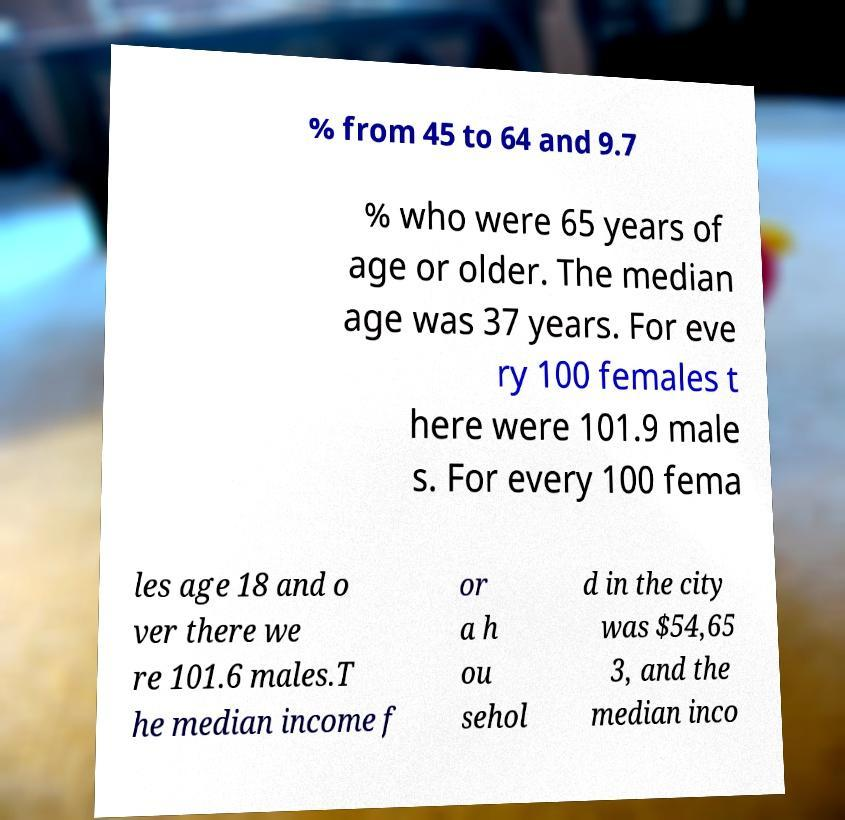What messages or text are displayed in this image? I need them in a readable, typed format. % from 45 to 64 and 9.7 % who were 65 years of age or older. The median age was 37 years. For eve ry 100 females t here were 101.9 male s. For every 100 fema les age 18 and o ver there we re 101.6 males.T he median income f or a h ou sehol d in the city was $54,65 3, and the median inco 